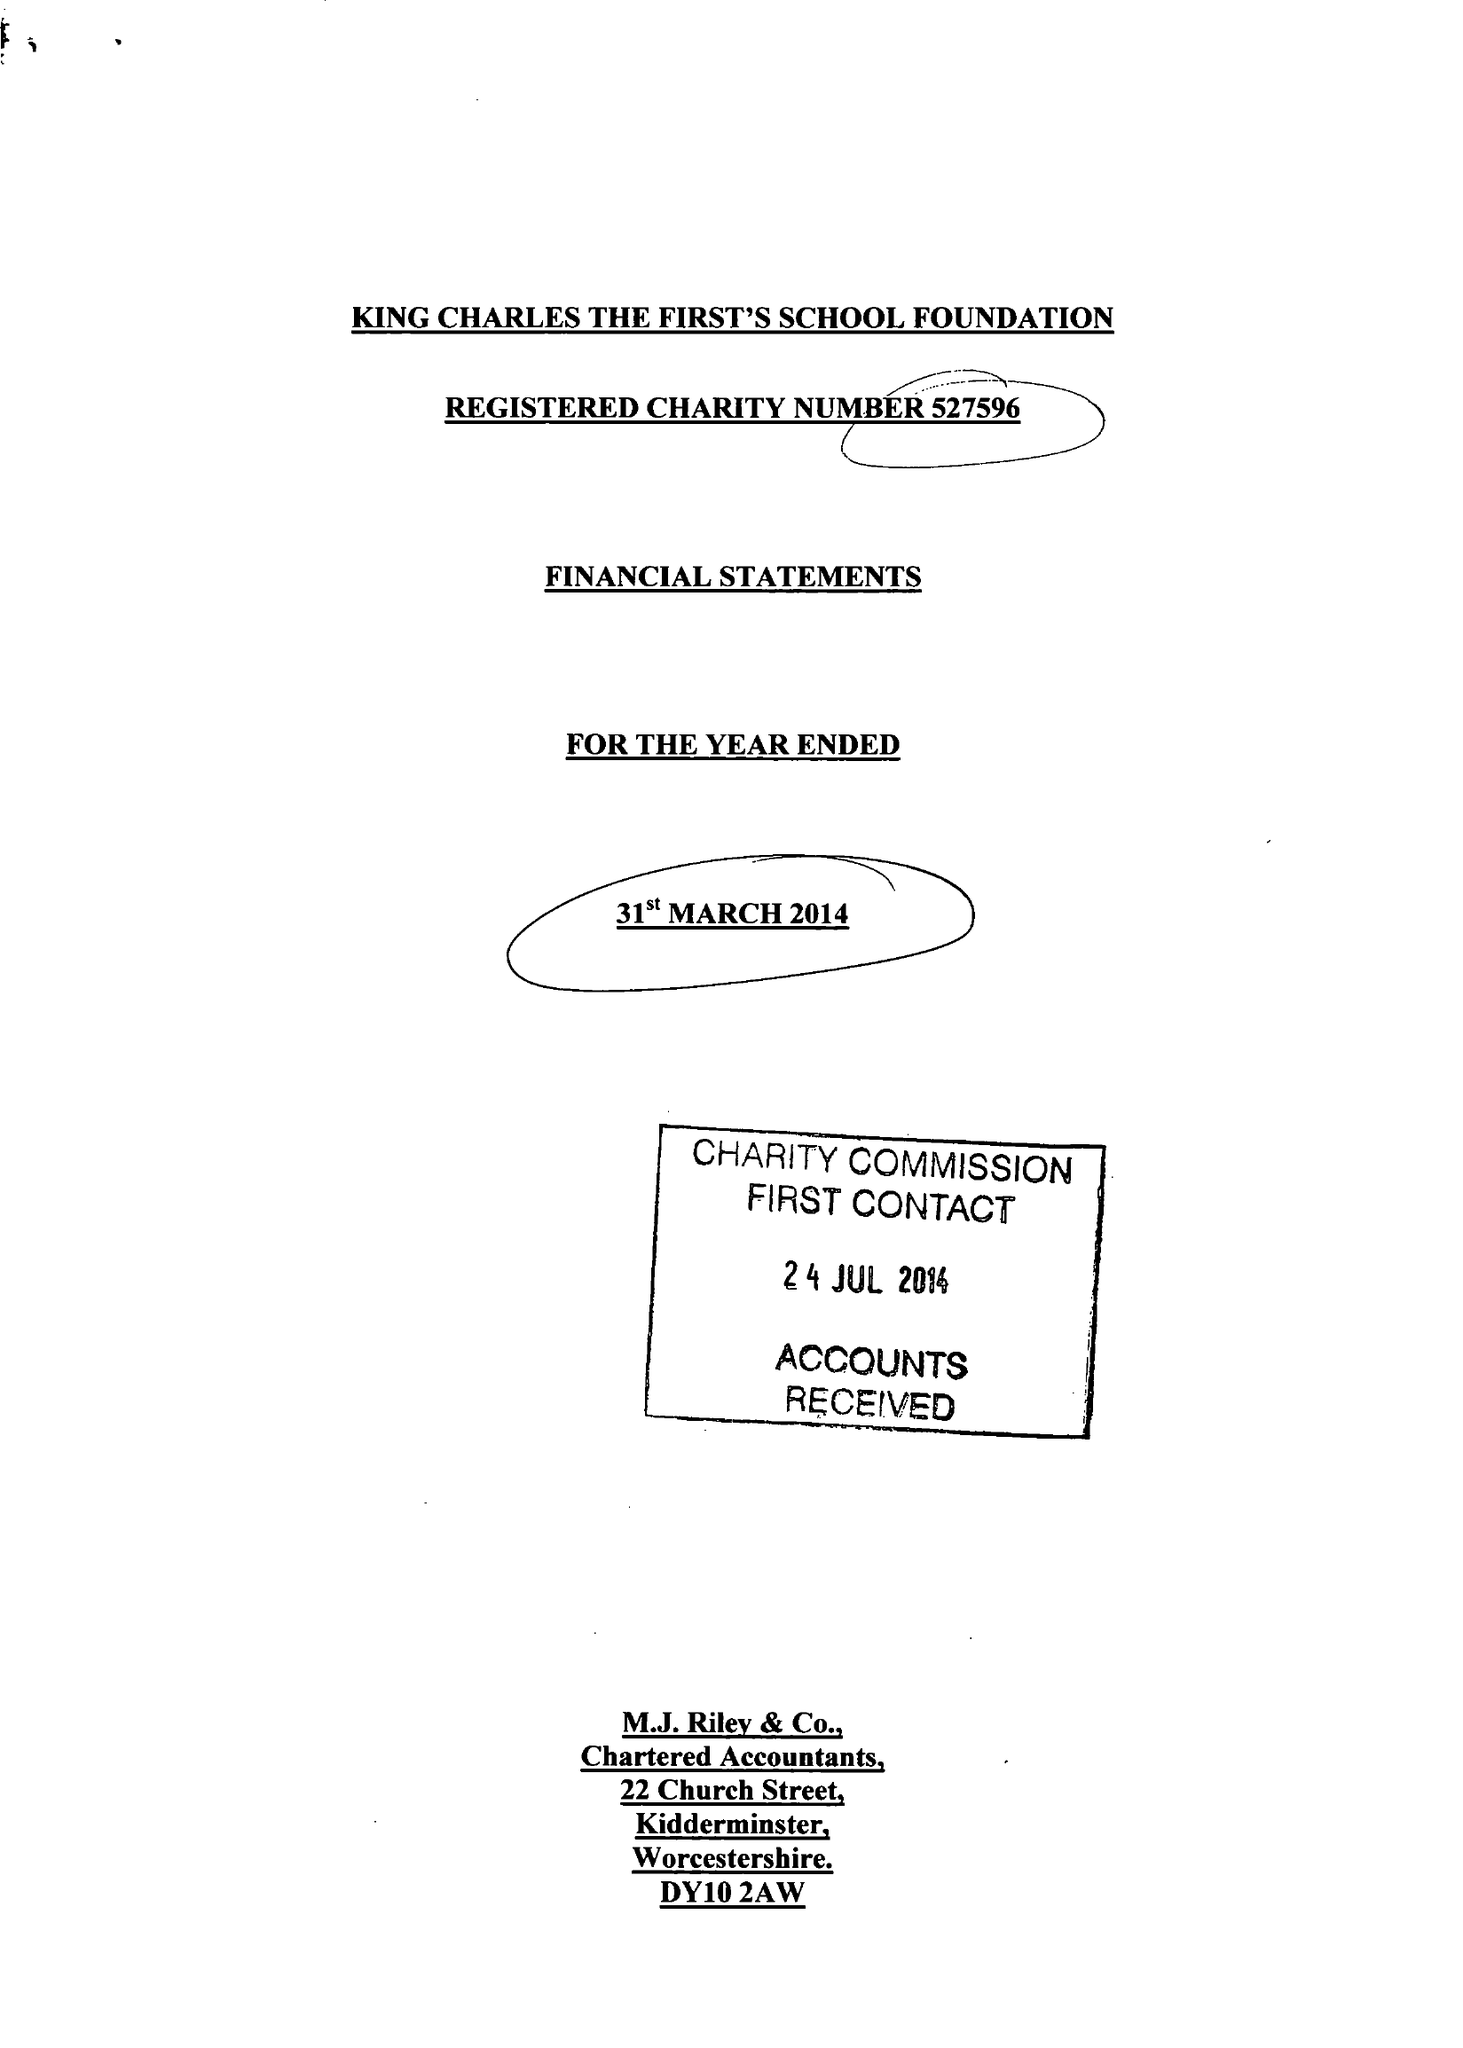What is the value for the report_date?
Answer the question using a single word or phrase. 2014-03-31 